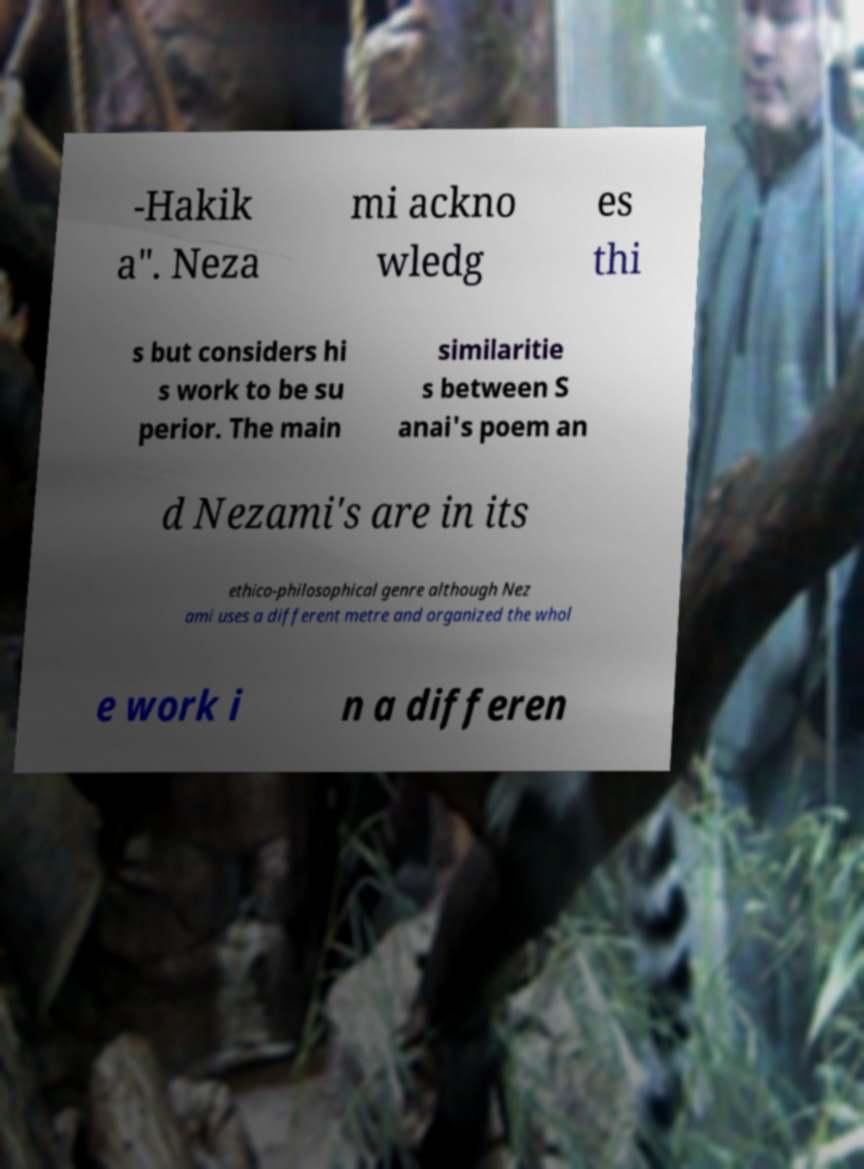Can you accurately transcribe the text from the provided image for me? -Hakik a". Neza mi ackno wledg es thi s but considers hi s work to be su perior. The main similaritie s between S anai's poem an d Nezami's are in its ethico-philosophical genre although Nez ami uses a different metre and organized the whol e work i n a differen 